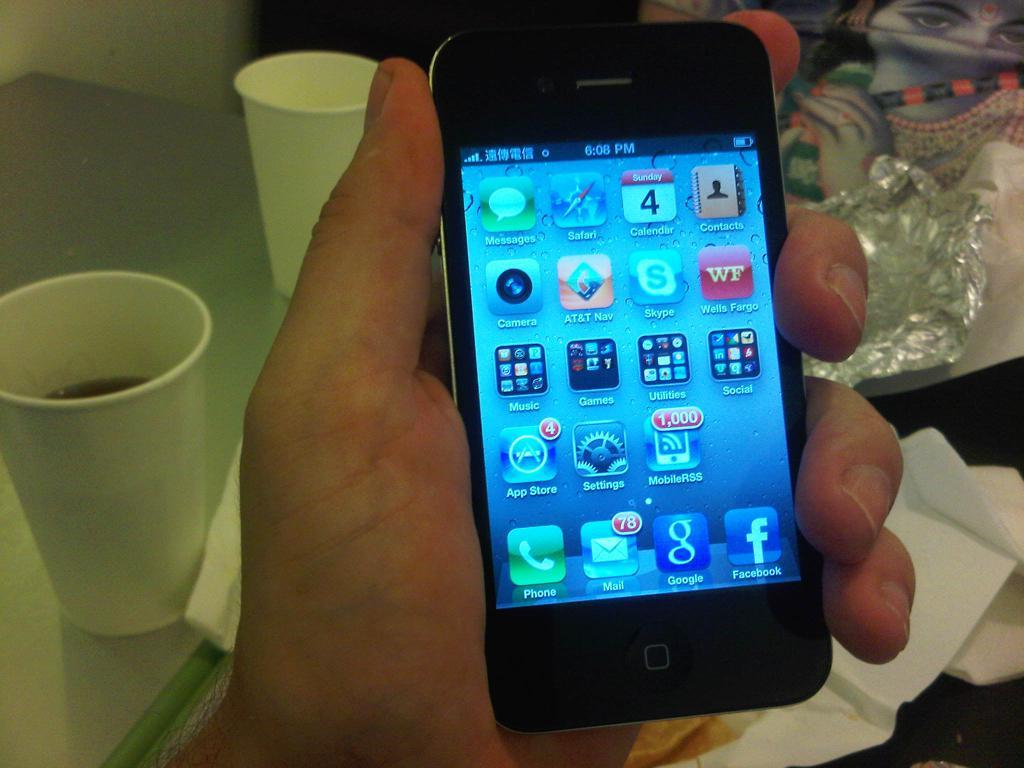<image>
Offer a succinct explanation of the picture presented. Someone is holding a cell phone that says it is 6:08 PM. 